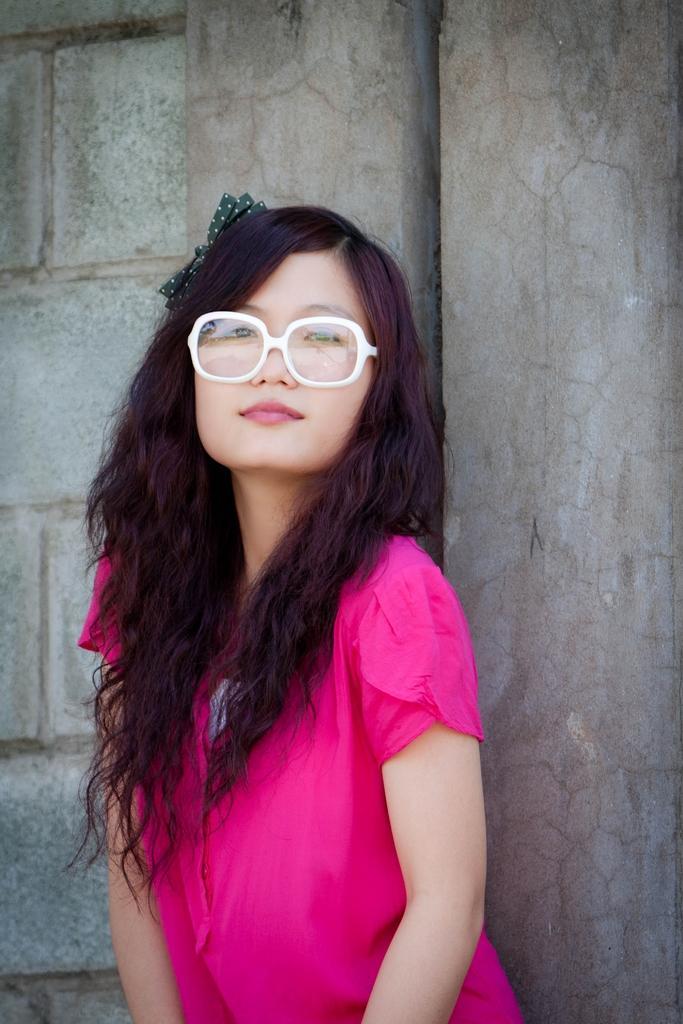Describe this image in one or two sentences. In this picture, we can see a woman in the pink dress is standing on the path and behind the woman there is a wall. 